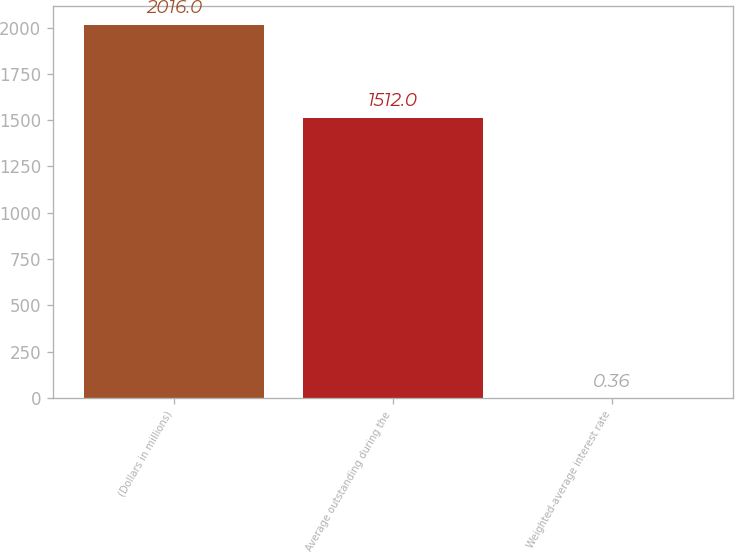Convert chart to OTSL. <chart><loc_0><loc_0><loc_500><loc_500><bar_chart><fcel>(Dollars in millions)<fcel>Average outstanding during the<fcel>Weighted-average interest rate<nl><fcel>2016<fcel>1512<fcel>0.36<nl></chart> 